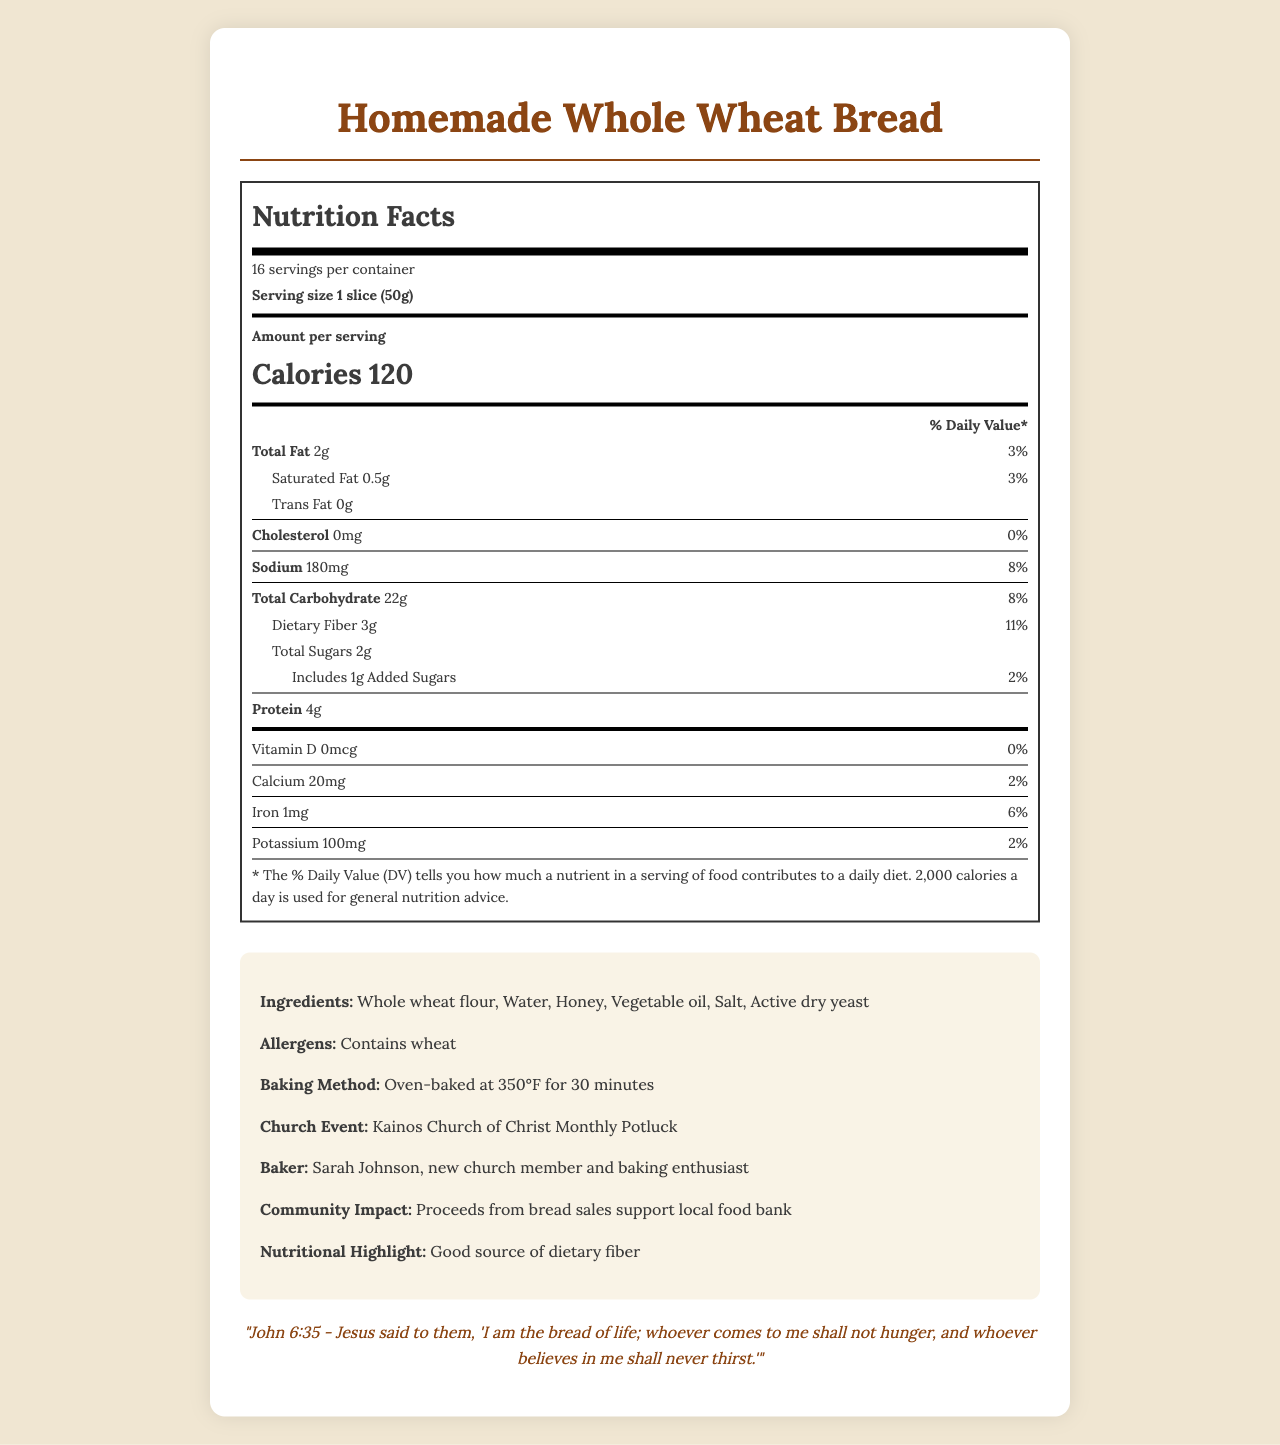what is the serving size of the Homemade Whole Wheat Bread? The serving size is specified as "1 slice (50g)" at the beginning of the Nutrition Facts section.
Answer: 1 slice (50g) How many servings are there per container? The document states "16 servings per container" in the Nutrition Facts section.
Answer: 16 What is the amount of sodium per serving? The amount of sodium per serving is listed as "Sodium 180 mg" in the Nutrition Facts section.
Answer: 180 mg How many grams of dietary fiber are in one serving? The document lists "Dietary Fiber 3 g" under the Total Carbohydrate section of the Nutrition Facts.
Answer: 3 g What percentage of the Daily Value is the Total Fat per serving? The Total Fat per serving is 2 grams, which is 3% of the daily value according to the Nutrition Facts.
Answer: 3% What ingredients are used in the Homemade Whole Wheat Bread? A. Whole wheat flour, Sugar, Water B. Whole wheat flour, Water, Honey C. Water, Salt, Butter According to the ingredients list in the extra information section, the ingredients are "Whole wheat flour, Water, Honey, Vegetable oil, Salt, Active dry yeast."
Answer: B Which of the following is NOT an allergen in this bread? A. Wheat B. Milk C. Gluten The document lists the allergen as "Contains wheat." Milk is not mentioned as an allergen.
Answer: B How much protein is in one slice of this bread? The amount of protein is listed as "Protein 4 g" in the Nutrition Facts section.
Answer: 4 g Does this bread contain any cholesterol? The Nutrition Facts section lists "Cholesterol 0 mg," indicating no cholesterol.
Answer: No What is the main community impact mentioned for this bread? The additional information section mentions that "Proceeds from bread sales support local food bank."
Answer: Proceeds from bread sales support local food bank Summarize the purpose of this document. The document is essentially a detailed label for Homemade Whole Wheat Bread that includes nutrition facts, ingredients, allergens, baking instructions, event information, and community impact details.
Answer: The document provides detailed Nutrition Facts for Homemade Whole Wheat Bread served at the Kainos Church of Christ Monthly Potluck, listing its ingredients, allergens, baking method, and community impact along with a scripture reference. How much Vitamin D is in one serving of this bread? The Nutrition Facts section states "Vitamin D 0 mcg," indicating no Vitamin D content in the bread.
Answer: 0 mcg What is the amount of added sugars per serving? The document lists "Includes 1 g Added Sugars" under the Total Sugars section of the Nutrition Facts.
Answer: 1 g Why does the bread have a good source of dietary fiber? According to the Nutrition Facts, the bread has 3 grams of dietary fiber per serving, which is 11% of the daily value.
Answer: Because it contains 3 grams of dietary fiber per serving, which is 11% of the daily value. Who baked the bread for the church potluck? The additional information section mentions the baker as "Sarah Johnson, new church member and baking enthusiast."
Answer: Sarah Johnson, new church member and baking enthusiast What temperature is the bread oven-baked at? The additional information section lists the baking method as "Oven-baked at 350°F for 30 minutes."
Answer: 350°F How many calories come from fat in one serving? The document provides the total calories per serving (120) and the amount of fat (2 g), but does not specify the exact calorie count from fat.
Answer: Not enough information 